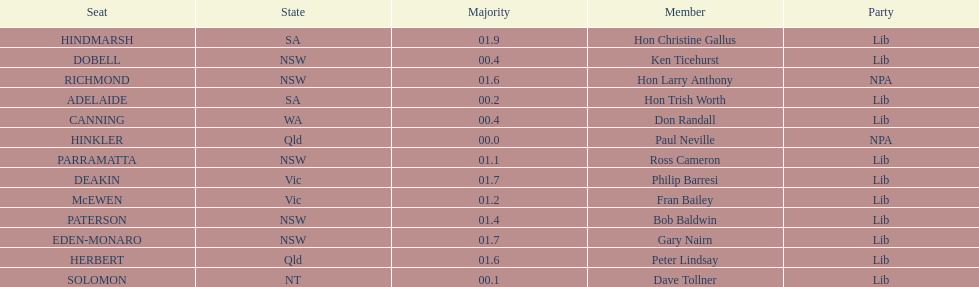What is the total of seats? 13. 